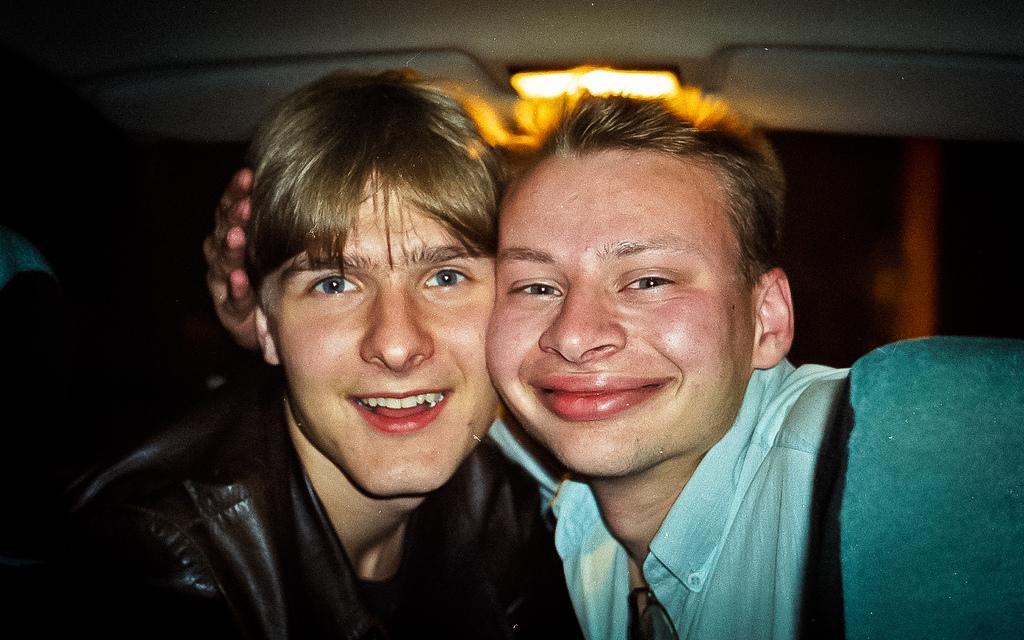Can you describe this image briefly? This image consist of two persons. There is light at the top. They are smiling. One is wearing a blue shirt, another one is wearing a black shirt. 